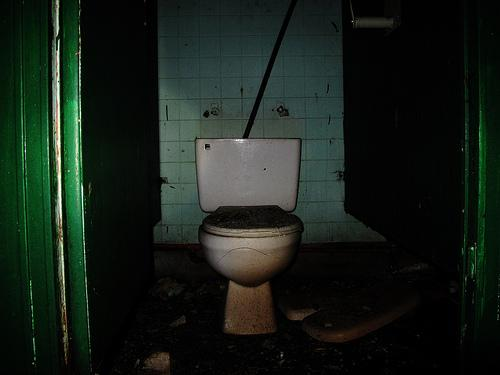Count the number of tiles described in the image. There are 11 tiles described. Identify the main color of the stall door and describe its condition. The stall door is green and it's part of an emerald green structure that seems worn and old. What is unusual about the toilet in this image? There is no lid on the top of the toilet, and the toilet tank lid is found on the floor. What adjectives would you use to describe the bathroom environment shown in the image? Dirty, unsanitary, neglected, and unpleasant. What main object caught your attention in the photograph? The white toilet without a lid in the dirty bathroom. Describe any noticeable damage or imperfections in the bathroom. There's a missing tile, a chip in another tile, a hole where the handle used to be, and dark marks on the wall. What can you say about the wall behind the toilet? The wall behind the toilet is tiled with dirty white tiles, having grime, dirt, and dark marks. Describe the condition of the toilet tank and lid. The toilet tank is white and missing its lid, which is on the dirty floor of the bathroom. List all the objects found in the image. White toilet stand, toilet tank lid, trash and dirt, toilet tank, toilet lid, toilet paper roll, green stall door, white toilet, dirty tile, missing tile, pole, trash, metal, brown lid, tiles, chip, hole, base, porcelain toilet, dark marks, emerald green structure, something on toilet seat, black line. What is the condition of the floor in the bathroom? The floor is covered in dirt, garbage, and trash making it quite dirty and unsanitary. 